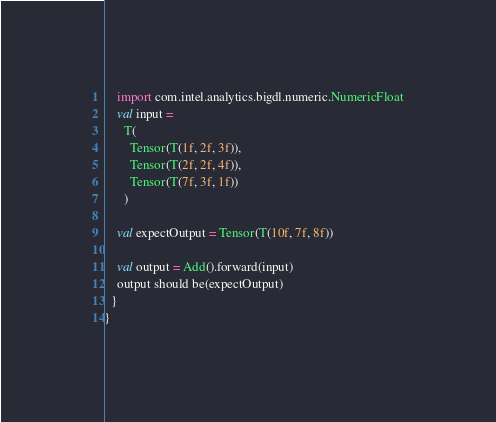<code> <loc_0><loc_0><loc_500><loc_500><_Scala_>    import com.intel.analytics.bigdl.numeric.NumericFloat
    val input =
      T(
        Tensor(T(1f, 2f, 3f)),
        Tensor(T(2f, 2f, 4f)),
        Tensor(T(7f, 3f, 1f))
      )

    val expectOutput = Tensor(T(10f, 7f, 8f))

    val output = Add().forward(input)
    output should be(expectOutput)
  }
}
</code> 